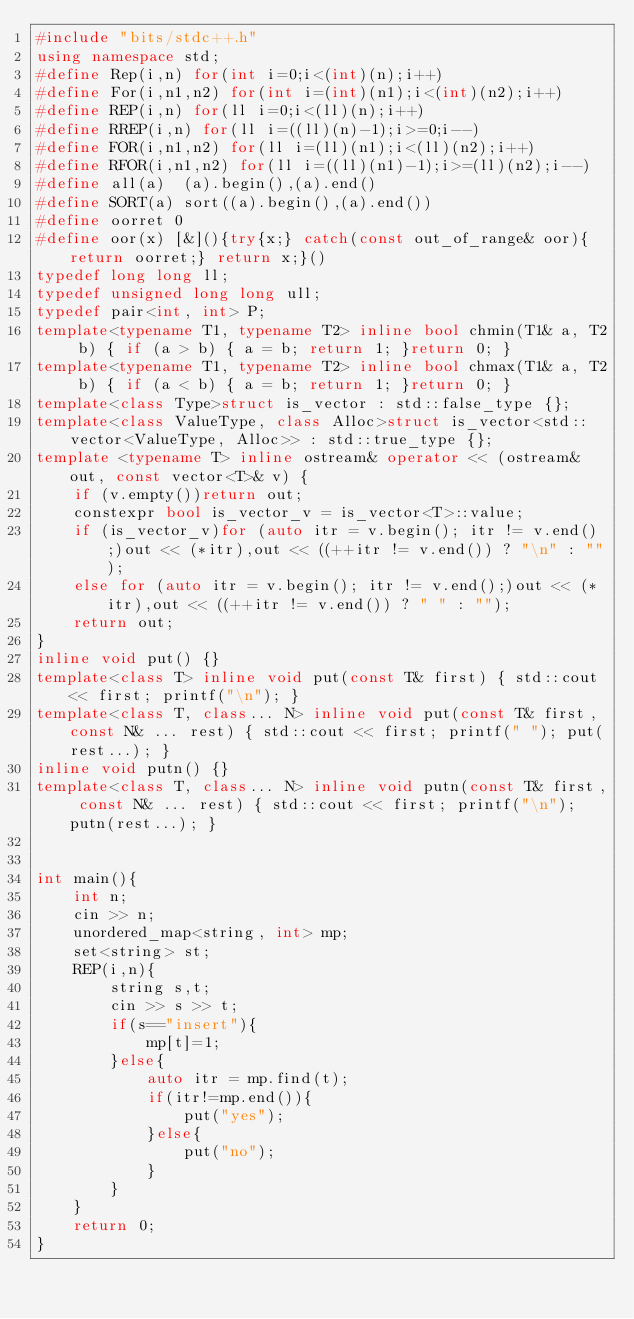Convert code to text. <code><loc_0><loc_0><loc_500><loc_500><_C++_>#include "bits/stdc++.h"
using namespace std;
#define Rep(i,n) for(int i=0;i<(int)(n);i++)
#define For(i,n1,n2) for(int i=(int)(n1);i<(int)(n2);i++)
#define REP(i,n) for(ll i=0;i<(ll)(n);i++)
#define RREP(i,n) for(ll i=((ll)(n)-1);i>=0;i--)
#define FOR(i,n1,n2) for(ll i=(ll)(n1);i<(ll)(n2);i++)
#define RFOR(i,n1,n2) for(ll i=((ll)(n1)-1);i>=(ll)(n2);i--)
#define all(a)  (a).begin(),(a).end()
#define SORT(a) sort((a).begin(),(a).end())
#define oorret 0
#define oor(x) [&](){try{x;} catch(const out_of_range& oor){return oorret;} return x;}()
typedef long long ll;
typedef unsigned long long ull;
typedef pair<int, int> P;
template<typename T1, typename T2> inline bool chmin(T1& a, T2 b) { if (a > b) { a = b; return 1; }return 0; }
template<typename T1, typename T2> inline bool chmax(T1& a, T2 b) { if (a < b) { a = b; return 1; }return 0; }
template<class Type>struct is_vector : std::false_type {};
template<class ValueType, class Alloc>struct is_vector<std::vector<ValueType, Alloc>> : std::true_type {};
template <typename T> inline ostream& operator << (ostream& out, const vector<T>& v) {
    if (v.empty())return out;
    constexpr bool is_vector_v = is_vector<T>::value;
    if (is_vector_v)for (auto itr = v.begin(); itr != v.end();)out << (*itr),out << ((++itr != v.end()) ? "\n" : "");
    else for (auto itr = v.begin(); itr != v.end();)out << (*itr),out << ((++itr != v.end()) ? " " : "");
    return out;
}
inline void put() {}
template<class T> inline void put(const T& first) { std::cout << first; printf("\n"); }
template<class T, class... N> inline void put(const T& first, const N& ... rest) { std::cout << first; printf(" "); put(rest...); }
inline void putn() {}
template<class T, class... N> inline void putn(const T& first, const N& ... rest) { std::cout << first; printf("\n"); putn(rest...); }


int main(){
    int n;
    cin >> n;
    unordered_map<string, int> mp;
    set<string> st;
    REP(i,n){
        string s,t;
        cin >> s >> t;
        if(s=="insert"){
            mp[t]=1;
        }else{
            auto itr = mp.find(t);
            if(itr!=mp.end()){
                put("yes");
            }else{
                put("no");
            }
        }
    }
    return 0;
}

</code> 